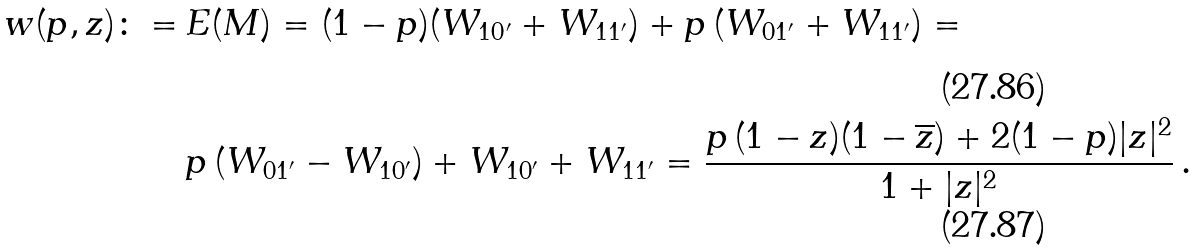<formula> <loc_0><loc_0><loc_500><loc_500>w ( p , z ) \colon = & \, E ( M ) = ( 1 - p ) ( W _ { 1 0 ^ { \prime } } + W _ { 1 1 ^ { \prime } } ) + p \, ( W _ { 0 1 ^ { \prime } } + W _ { 1 1 ^ { \prime } } ) = \\ & \, p \, ( W _ { 0 1 ^ { \prime } } - W _ { 1 0 ^ { \prime } } ) + W _ { 1 0 ^ { \prime } } + W _ { 1 1 ^ { \prime } } = \frac { p \, ( 1 - z ) ( 1 - \overline { z } ) + 2 ( 1 - p ) | z | ^ { 2 } } { 1 + | z | ^ { 2 } } \, .</formula> 